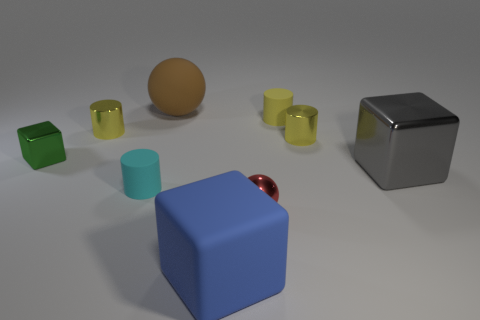Subtract all blue spheres. How many yellow cylinders are left? 3 Add 1 big blue matte objects. How many objects exist? 10 Subtract all balls. How many objects are left? 7 Add 7 tiny green metallic cubes. How many tiny green metallic cubes are left? 8 Add 6 red metal spheres. How many red metal spheres exist? 7 Subtract 1 green cubes. How many objects are left? 8 Subtract all tiny green matte things. Subtract all small red things. How many objects are left? 8 